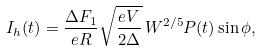Convert formula to latex. <formula><loc_0><loc_0><loc_500><loc_500>I _ { h } ( t ) = \frac { \Delta F _ { 1 } } { e R } \sqrt { \frac { e V } { 2 \Delta } } \, W ^ { 2 / 5 } P ( t ) \sin \phi ,</formula> 